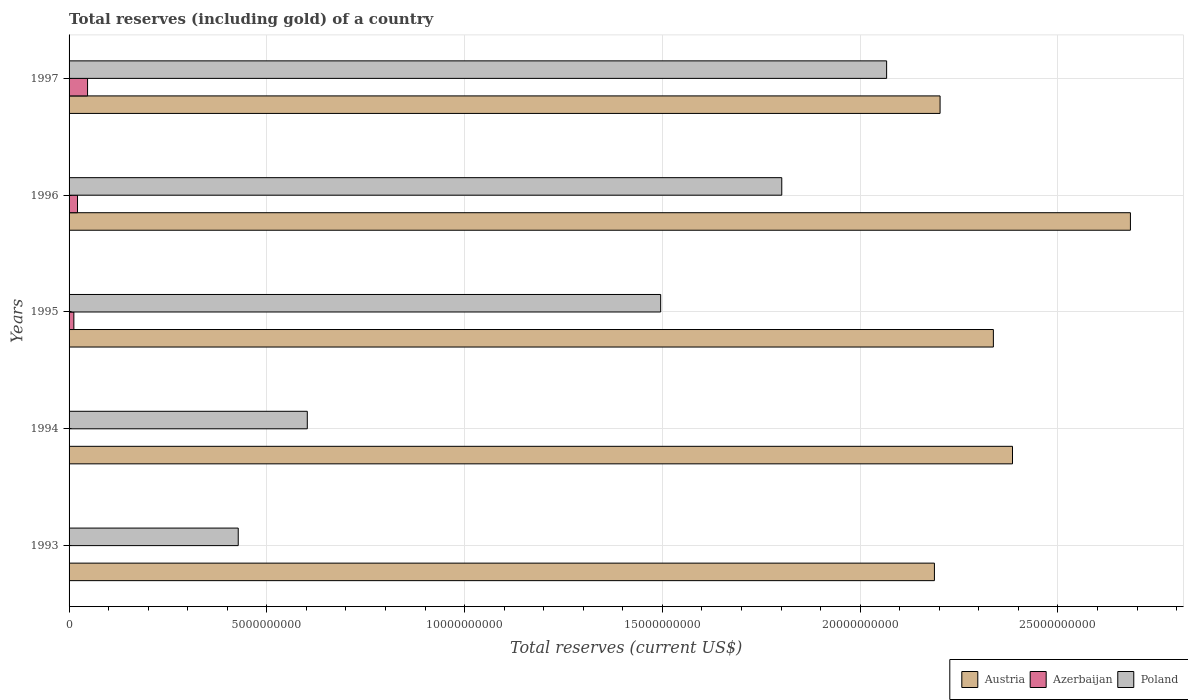How many different coloured bars are there?
Provide a succinct answer. 3. Are the number of bars per tick equal to the number of legend labels?
Keep it short and to the point. Yes. Are the number of bars on each tick of the Y-axis equal?
Your response must be concise. Yes. How many bars are there on the 5th tick from the bottom?
Give a very brief answer. 3. What is the total reserves (including gold) in Azerbaijan in 1994?
Ensure brevity in your answer.  2.03e+06. Across all years, what is the maximum total reserves (including gold) in Austria?
Your response must be concise. 2.68e+1. Across all years, what is the minimum total reserves (including gold) in Poland?
Ensure brevity in your answer.  4.28e+09. What is the total total reserves (including gold) in Poland in the graph?
Your answer should be very brief. 6.39e+1. What is the difference between the total reserves (including gold) in Azerbaijan in 1996 and that in 1997?
Your answer should be very brief. -2.54e+08. What is the difference between the total reserves (including gold) in Poland in 1996 and the total reserves (including gold) in Azerbaijan in 1995?
Your answer should be compact. 1.79e+1. What is the average total reserves (including gold) in Azerbaijan per year?
Keep it short and to the point. 1.61e+08. In the year 1996, what is the difference between the total reserves (including gold) in Poland and total reserves (including gold) in Austria?
Make the answer very short. -8.81e+09. What is the ratio of the total reserves (including gold) in Azerbaijan in 1994 to that in 1997?
Provide a short and direct response. 0. Is the total reserves (including gold) in Azerbaijan in 1996 less than that in 1997?
Give a very brief answer. Yes. Is the difference between the total reserves (including gold) in Poland in 1994 and 1995 greater than the difference between the total reserves (including gold) in Austria in 1994 and 1995?
Offer a terse response. No. What is the difference between the highest and the second highest total reserves (including gold) in Poland?
Offer a terse response. 2.65e+09. What is the difference between the highest and the lowest total reserves (including gold) in Poland?
Make the answer very short. 1.64e+1. What does the 1st bar from the bottom in 1993 represents?
Keep it short and to the point. Austria. How many bars are there?
Offer a very short reply. 15. Are all the bars in the graph horizontal?
Your answer should be compact. Yes. How many years are there in the graph?
Your answer should be compact. 5. Does the graph contain any zero values?
Ensure brevity in your answer.  No. How many legend labels are there?
Your answer should be compact. 3. What is the title of the graph?
Give a very brief answer. Total reserves (including gold) of a country. Does "Caribbean small states" appear as one of the legend labels in the graph?
Offer a terse response. No. What is the label or title of the X-axis?
Your answer should be compact. Total reserves (current US$). What is the label or title of the Y-axis?
Your answer should be very brief. Years. What is the Total reserves (current US$) in Austria in 1993?
Provide a succinct answer. 2.19e+1. What is the Total reserves (current US$) of Azerbaijan in 1993?
Provide a short and direct response. 5.90e+05. What is the Total reserves (current US$) of Poland in 1993?
Your answer should be compact. 4.28e+09. What is the Total reserves (current US$) in Austria in 1994?
Provide a succinct answer. 2.39e+1. What is the Total reserves (current US$) of Azerbaijan in 1994?
Your answer should be compact. 2.03e+06. What is the Total reserves (current US$) in Poland in 1994?
Make the answer very short. 6.02e+09. What is the Total reserves (current US$) of Austria in 1995?
Your response must be concise. 2.34e+1. What is the Total reserves (current US$) of Azerbaijan in 1995?
Give a very brief answer. 1.21e+08. What is the Total reserves (current US$) of Poland in 1995?
Your response must be concise. 1.50e+1. What is the Total reserves (current US$) in Austria in 1996?
Offer a terse response. 2.68e+1. What is the Total reserves (current US$) of Azerbaijan in 1996?
Your answer should be compact. 2.14e+08. What is the Total reserves (current US$) in Poland in 1996?
Provide a short and direct response. 1.80e+1. What is the Total reserves (current US$) in Austria in 1997?
Make the answer very short. 2.20e+1. What is the Total reserves (current US$) in Azerbaijan in 1997?
Your response must be concise. 4.67e+08. What is the Total reserves (current US$) of Poland in 1997?
Your response must be concise. 2.07e+1. Across all years, what is the maximum Total reserves (current US$) of Austria?
Your answer should be compact. 2.68e+1. Across all years, what is the maximum Total reserves (current US$) in Azerbaijan?
Offer a very short reply. 4.67e+08. Across all years, what is the maximum Total reserves (current US$) of Poland?
Your answer should be very brief. 2.07e+1. Across all years, what is the minimum Total reserves (current US$) of Austria?
Provide a short and direct response. 2.19e+1. Across all years, what is the minimum Total reserves (current US$) of Azerbaijan?
Provide a short and direct response. 5.90e+05. Across all years, what is the minimum Total reserves (current US$) of Poland?
Provide a short and direct response. 4.28e+09. What is the total Total reserves (current US$) in Austria in the graph?
Keep it short and to the point. 1.18e+11. What is the total Total reserves (current US$) in Azerbaijan in the graph?
Make the answer very short. 8.04e+08. What is the total Total reserves (current US$) in Poland in the graph?
Ensure brevity in your answer.  6.39e+1. What is the difference between the Total reserves (current US$) in Austria in 1993 and that in 1994?
Your answer should be compact. -1.97e+09. What is the difference between the Total reserves (current US$) of Azerbaijan in 1993 and that in 1994?
Offer a terse response. -1.44e+06. What is the difference between the Total reserves (current US$) in Poland in 1993 and that in 1994?
Your answer should be very brief. -1.75e+09. What is the difference between the Total reserves (current US$) in Austria in 1993 and that in 1995?
Provide a succinct answer. -1.49e+09. What is the difference between the Total reserves (current US$) of Azerbaijan in 1993 and that in 1995?
Offer a very short reply. -1.20e+08. What is the difference between the Total reserves (current US$) of Poland in 1993 and that in 1995?
Give a very brief answer. -1.07e+1. What is the difference between the Total reserves (current US$) of Austria in 1993 and that in 1996?
Your response must be concise. -4.96e+09. What is the difference between the Total reserves (current US$) of Azerbaijan in 1993 and that in 1996?
Ensure brevity in your answer.  -2.13e+08. What is the difference between the Total reserves (current US$) in Poland in 1993 and that in 1996?
Your answer should be compact. -1.37e+1. What is the difference between the Total reserves (current US$) of Austria in 1993 and that in 1997?
Your answer should be very brief. -1.43e+08. What is the difference between the Total reserves (current US$) in Azerbaijan in 1993 and that in 1997?
Your answer should be compact. -4.67e+08. What is the difference between the Total reserves (current US$) in Poland in 1993 and that in 1997?
Ensure brevity in your answer.  -1.64e+1. What is the difference between the Total reserves (current US$) in Austria in 1994 and that in 1995?
Your response must be concise. 4.83e+08. What is the difference between the Total reserves (current US$) of Azerbaijan in 1994 and that in 1995?
Ensure brevity in your answer.  -1.19e+08. What is the difference between the Total reserves (current US$) of Poland in 1994 and that in 1995?
Provide a succinct answer. -8.93e+09. What is the difference between the Total reserves (current US$) of Austria in 1994 and that in 1996?
Your response must be concise. -2.98e+09. What is the difference between the Total reserves (current US$) in Azerbaijan in 1994 and that in 1996?
Ensure brevity in your answer.  -2.12e+08. What is the difference between the Total reserves (current US$) in Poland in 1994 and that in 1996?
Keep it short and to the point. -1.20e+1. What is the difference between the Total reserves (current US$) in Austria in 1994 and that in 1997?
Your response must be concise. 1.83e+09. What is the difference between the Total reserves (current US$) of Azerbaijan in 1994 and that in 1997?
Offer a very short reply. -4.65e+08. What is the difference between the Total reserves (current US$) of Poland in 1994 and that in 1997?
Your answer should be compact. -1.46e+1. What is the difference between the Total reserves (current US$) of Austria in 1995 and that in 1996?
Keep it short and to the point. -3.46e+09. What is the difference between the Total reserves (current US$) in Azerbaijan in 1995 and that in 1996?
Offer a terse response. -9.28e+07. What is the difference between the Total reserves (current US$) in Poland in 1995 and that in 1996?
Provide a succinct answer. -3.06e+09. What is the difference between the Total reserves (current US$) of Austria in 1995 and that in 1997?
Ensure brevity in your answer.  1.35e+09. What is the difference between the Total reserves (current US$) in Azerbaijan in 1995 and that in 1997?
Give a very brief answer. -3.46e+08. What is the difference between the Total reserves (current US$) in Poland in 1995 and that in 1997?
Your response must be concise. -5.71e+09. What is the difference between the Total reserves (current US$) in Austria in 1996 and that in 1997?
Make the answer very short. 4.81e+09. What is the difference between the Total reserves (current US$) in Azerbaijan in 1996 and that in 1997?
Your answer should be compact. -2.54e+08. What is the difference between the Total reserves (current US$) of Poland in 1996 and that in 1997?
Ensure brevity in your answer.  -2.65e+09. What is the difference between the Total reserves (current US$) of Austria in 1993 and the Total reserves (current US$) of Azerbaijan in 1994?
Offer a terse response. 2.19e+1. What is the difference between the Total reserves (current US$) in Austria in 1993 and the Total reserves (current US$) in Poland in 1994?
Offer a very short reply. 1.59e+1. What is the difference between the Total reserves (current US$) of Azerbaijan in 1993 and the Total reserves (current US$) of Poland in 1994?
Give a very brief answer. -6.02e+09. What is the difference between the Total reserves (current US$) in Austria in 1993 and the Total reserves (current US$) in Azerbaijan in 1995?
Give a very brief answer. 2.18e+1. What is the difference between the Total reserves (current US$) of Austria in 1993 and the Total reserves (current US$) of Poland in 1995?
Keep it short and to the point. 6.92e+09. What is the difference between the Total reserves (current US$) of Azerbaijan in 1993 and the Total reserves (current US$) of Poland in 1995?
Your answer should be very brief. -1.50e+1. What is the difference between the Total reserves (current US$) in Austria in 1993 and the Total reserves (current US$) in Azerbaijan in 1996?
Make the answer very short. 2.17e+1. What is the difference between the Total reserves (current US$) of Austria in 1993 and the Total reserves (current US$) of Poland in 1996?
Offer a terse response. 3.86e+09. What is the difference between the Total reserves (current US$) in Azerbaijan in 1993 and the Total reserves (current US$) in Poland in 1996?
Ensure brevity in your answer.  -1.80e+1. What is the difference between the Total reserves (current US$) of Austria in 1993 and the Total reserves (current US$) of Azerbaijan in 1997?
Offer a very short reply. 2.14e+1. What is the difference between the Total reserves (current US$) of Austria in 1993 and the Total reserves (current US$) of Poland in 1997?
Make the answer very short. 1.21e+09. What is the difference between the Total reserves (current US$) of Azerbaijan in 1993 and the Total reserves (current US$) of Poland in 1997?
Your answer should be compact. -2.07e+1. What is the difference between the Total reserves (current US$) in Austria in 1994 and the Total reserves (current US$) in Azerbaijan in 1995?
Provide a succinct answer. 2.37e+1. What is the difference between the Total reserves (current US$) in Austria in 1994 and the Total reserves (current US$) in Poland in 1995?
Keep it short and to the point. 8.90e+09. What is the difference between the Total reserves (current US$) in Azerbaijan in 1994 and the Total reserves (current US$) in Poland in 1995?
Your answer should be compact. -1.50e+1. What is the difference between the Total reserves (current US$) of Austria in 1994 and the Total reserves (current US$) of Azerbaijan in 1996?
Your answer should be compact. 2.36e+1. What is the difference between the Total reserves (current US$) of Austria in 1994 and the Total reserves (current US$) of Poland in 1996?
Provide a succinct answer. 5.83e+09. What is the difference between the Total reserves (current US$) of Azerbaijan in 1994 and the Total reserves (current US$) of Poland in 1996?
Provide a succinct answer. -1.80e+1. What is the difference between the Total reserves (current US$) in Austria in 1994 and the Total reserves (current US$) in Azerbaijan in 1997?
Your response must be concise. 2.34e+1. What is the difference between the Total reserves (current US$) in Austria in 1994 and the Total reserves (current US$) in Poland in 1997?
Offer a terse response. 3.18e+09. What is the difference between the Total reserves (current US$) of Azerbaijan in 1994 and the Total reserves (current US$) of Poland in 1997?
Give a very brief answer. -2.07e+1. What is the difference between the Total reserves (current US$) of Austria in 1995 and the Total reserves (current US$) of Azerbaijan in 1996?
Keep it short and to the point. 2.32e+1. What is the difference between the Total reserves (current US$) of Austria in 1995 and the Total reserves (current US$) of Poland in 1996?
Provide a succinct answer. 5.35e+09. What is the difference between the Total reserves (current US$) of Azerbaijan in 1995 and the Total reserves (current US$) of Poland in 1996?
Make the answer very short. -1.79e+1. What is the difference between the Total reserves (current US$) of Austria in 1995 and the Total reserves (current US$) of Azerbaijan in 1997?
Provide a succinct answer. 2.29e+1. What is the difference between the Total reserves (current US$) in Austria in 1995 and the Total reserves (current US$) in Poland in 1997?
Give a very brief answer. 2.70e+09. What is the difference between the Total reserves (current US$) of Azerbaijan in 1995 and the Total reserves (current US$) of Poland in 1997?
Offer a very short reply. -2.05e+1. What is the difference between the Total reserves (current US$) of Austria in 1996 and the Total reserves (current US$) of Azerbaijan in 1997?
Offer a terse response. 2.64e+1. What is the difference between the Total reserves (current US$) in Austria in 1996 and the Total reserves (current US$) in Poland in 1997?
Provide a succinct answer. 6.16e+09. What is the difference between the Total reserves (current US$) in Azerbaijan in 1996 and the Total reserves (current US$) in Poland in 1997?
Your response must be concise. -2.05e+1. What is the average Total reserves (current US$) of Austria per year?
Give a very brief answer. 2.36e+1. What is the average Total reserves (current US$) in Azerbaijan per year?
Your answer should be compact. 1.61e+08. What is the average Total reserves (current US$) of Poland per year?
Give a very brief answer. 1.28e+1. In the year 1993, what is the difference between the Total reserves (current US$) of Austria and Total reserves (current US$) of Azerbaijan?
Your answer should be very brief. 2.19e+1. In the year 1993, what is the difference between the Total reserves (current US$) of Austria and Total reserves (current US$) of Poland?
Provide a short and direct response. 1.76e+1. In the year 1993, what is the difference between the Total reserves (current US$) of Azerbaijan and Total reserves (current US$) of Poland?
Make the answer very short. -4.28e+09. In the year 1994, what is the difference between the Total reserves (current US$) in Austria and Total reserves (current US$) in Azerbaijan?
Make the answer very short. 2.39e+1. In the year 1994, what is the difference between the Total reserves (current US$) in Austria and Total reserves (current US$) in Poland?
Ensure brevity in your answer.  1.78e+1. In the year 1994, what is the difference between the Total reserves (current US$) in Azerbaijan and Total reserves (current US$) in Poland?
Your answer should be very brief. -6.02e+09. In the year 1995, what is the difference between the Total reserves (current US$) in Austria and Total reserves (current US$) in Azerbaijan?
Your answer should be compact. 2.32e+1. In the year 1995, what is the difference between the Total reserves (current US$) of Austria and Total reserves (current US$) of Poland?
Your response must be concise. 8.41e+09. In the year 1995, what is the difference between the Total reserves (current US$) of Azerbaijan and Total reserves (current US$) of Poland?
Offer a very short reply. -1.48e+1. In the year 1996, what is the difference between the Total reserves (current US$) in Austria and Total reserves (current US$) in Azerbaijan?
Offer a very short reply. 2.66e+1. In the year 1996, what is the difference between the Total reserves (current US$) in Austria and Total reserves (current US$) in Poland?
Keep it short and to the point. 8.81e+09. In the year 1996, what is the difference between the Total reserves (current US$) of Azerbaijan and Total reserves (current US$) of Poland?
Make the answer very short. -1.78e+1. In the year 1997, what is the difference between the Total reserves (current US$) of Austria and Total reserves (current US$) of Azerbaijan?
Your answer should be very brief. 2.16e+1. In the year 1997, what is the difference between the Total reserves (current US$) in Austria and Total reserves (current US$) in Poland?
Give a very brief answer. 1.35e+09. In the year 1997, what is the difference between the Total reserves (current US$) of Azerbaijan and Total reserves (current US$) of Poland?
Offer a very short reply. -2.02e+1. What is the ratio of the Total reserves (current US$) in Austria in 1993 to that in 1994?
Your answer should be very brief. 0.92. What is the ratio of the Total reserves (current US$) of Azerbaijan in 1993 to that in 1994?
Give a very brief answer. 0.29. What is the ratio of the Total reserves (current US$) in Poland in 1993 to that in 1994?
Your answer should be very brief. 0.71. What is the ratio of the Total reserves (current US$) of Austria in 1993 to that in 1995?
Provide a succinct answer. 0.94. What is the ratio of the Total reserves (current US$) of Azerbaijan in 1993 to that in 1995?
Make the answer very short. 0. What is the ratio of the Total reserves (current US$) of Poland in 1993 to that in 1995?
Your answer should be very brief. 0.29. What is the ratio of the Total reserves (current US$) of Austria in 1993 to that in 1996?
Your response must be concise. 0.82. What is the ratio of the Total reserves (current US$) in Azerbaijan in 1993 to that in 1996?
Give a very brief answer. 0. What is the ratio of the Total reserves (current US$) in Poland in 1993 to that in 1996?
Provide a succinct answer. 0.24. What is the ratio of the Total reserves (current US$) of Austria in 1993 to that in 1997?
Your response must be concise. 0.99. What is the ratio of the Total reserves (current US$) of Azerbaijan in 1993 to that in 1997?
Offer a very short reply. 0. What is the ratio of the Total reserves (current US$) of Poland in 1993 to that in 1997?
Keep it short and to the point. 0.21. What is the ratio of the Total reserves (current US$) of Austria in 1994 to that in 1995?
Give a very brief answer. 1.02. What is the ratio of the Total reserves (current US$) of Azerbaijan in 1994 to that in 1995?
Make the answer very short. 0.02. What is the ratio of the Total reserves (current US$) in Poland in 1994 to that in 1995?
Ensure brevity in your answer.  0.4. What is the ratio of the Total reserves (current US$) in Austria in 1994 to that in 1996?
Offer a very short reply. 0.89. What is the ratio of the Total reserves (current US$) of Azerbaijan in 1994 to that in 1996?
Ensure brevity in your answer.  0.01. What is the ratio of the Total reserves (current US$) of Poland in 1994 to that in 1996?
Your answer should be very brief. 0.33. What is the ratio of the Total reserves (current US$) in Austria in 1994 to that in 1997?
Your answer should be very brief. 1.08. What is the ratio of the Total reserves (current US$) of Azerbaijan in 1994 to that in 1997?
Provide a short and direct response. 0. What is the ratio of the Total reserves (current US$) in Poland in 1994 to that in 1997?
Offer a very short reply. 0.29. What is the ratio of the Total reserves (current US$) of Austria in 1995 to that in 1996?
Your response must be concise. 0.87. What is the ratio of the Total reserves (current US$) of Azerbaijan in 1995 to that in 1996?
Provide a short and direct response. 0.57. What is the ratio of the Total reserves (current US$) of Poland in 1995 to that in 1996?
Provide a succinct answer. 0.83. What is the ratio of the Total reserves (current US$) in Austria in 1995 to that in 1997?
Ensure brevity in your answer.  1.06. What is the ratio of the Total reserves (current US$) of Azerbaijan in 1995 to that in 1997?
Make the answer very short. 0.26. What is the ratio of the Total reserves (current US$) of Poland in 1995 to that in 1997?
Offer a very short reply. 0.72. What is the ratio of the Total reserves (current US$) of Austria in 1996 to that in 1997?
Your answer should be compact. 1.22. What is the ratio of the Total reserves (current US$) of Azerbaijan in 1996 to that in 1997?
Ensure brevity in your answer.  0.46. What is the ratio of the Total reserves (current US$) in Poland in 1996 to that in 1997?
Keep it short and to the point. 0.87. What is the difference between the highest and the second highest Total reserves (current US$) of Austria?
Your response must be concise. 2.98e+09. What is the difference between the highest and the second highest Total reserves (current US$) of Azerbaijan?
Your answer should be very brief. 2.54e+08. What is the difference between the highest and the second highest Total reserves (current US$) of Poland?
Your response must be concise. 2.65e+09. What is the difference between the highest and the lowest Total reserves (current US$) of Austria?
Offer a terse response. 4.96e+09. What is the difference between the highest and the lowest Total reserves (current US$) in Azerbaijan?
Give a very brief answer. 4.67e+08. What is the difference between the highest and the lowest Total reserves (current US$) of Poland?
Ensure brevity in your answer.  1.64e+1. 